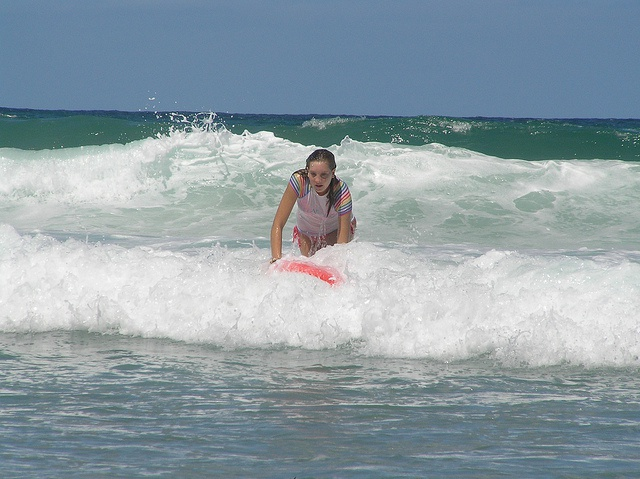Describe the objects in this image and their specific colors. I can see people in gray and black tones and surfboard in gray, lightpink, lightgray, salmon, and pink tones in this image. 